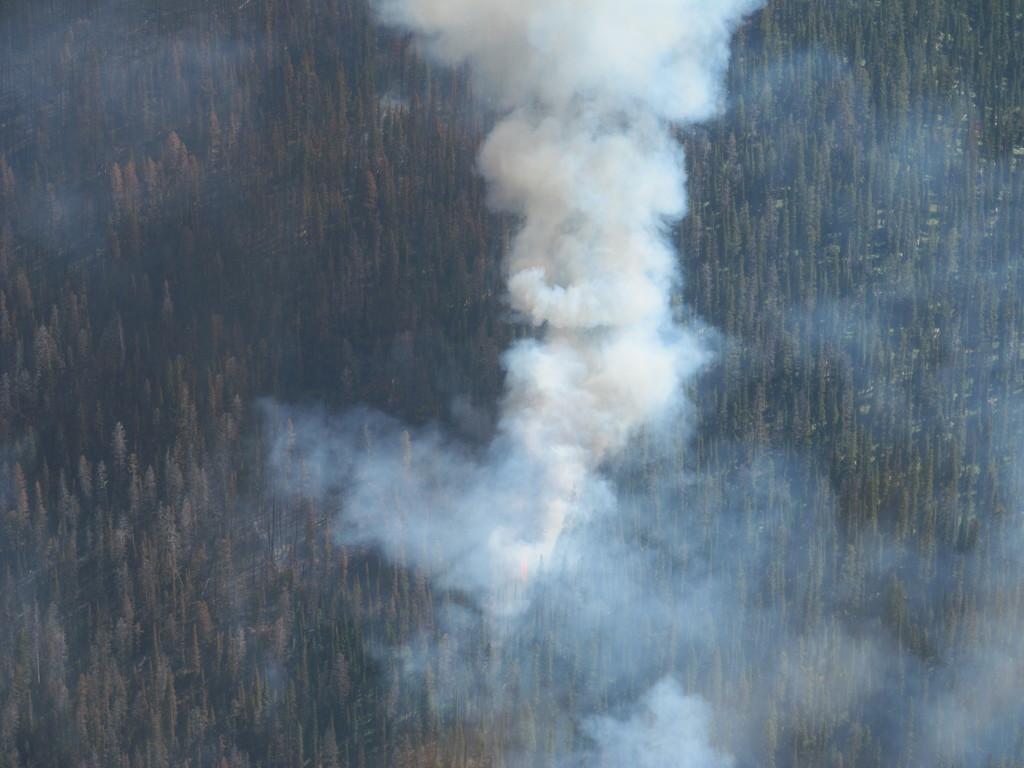Can you describe this image briefly? In this given picture, I can see a smoke couple of trees. 